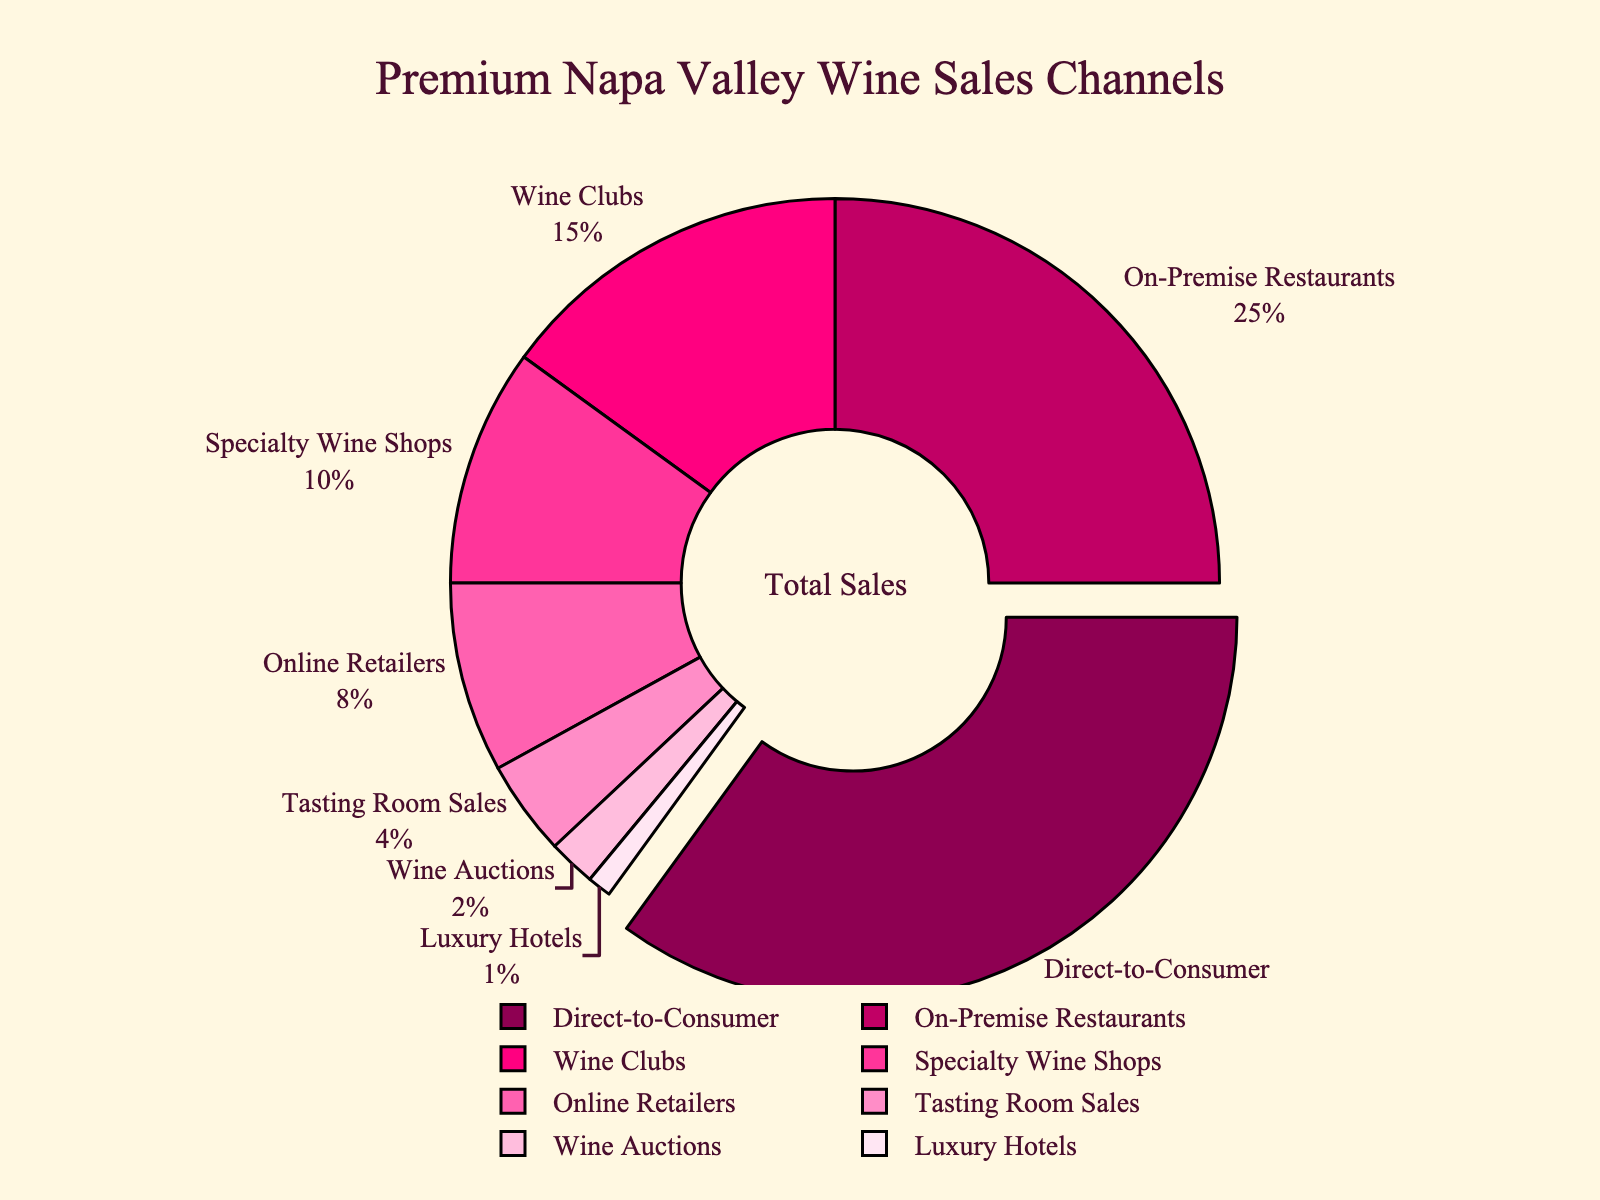what is the largest sales channel for premium Napa Valley wines? The largest sales channel is determined by the section with the greatest percentage. In this case, the "Direct-to-Consumer" section is pulled out and shows 35%
Answer: Direct-to-Consumer what percentage of sales is contributed by Wine Clubs and Specialty Wine Shops combined? Add the percentages of Wine Clubs (15%) and Specialty Wine Shops (10%). So, 15% + 10% = 25%
Answer: 25% which channel has the smallest share? Look for the smallest section in the pie chart. "Luxury Hotels" has the smallest share at 1%
Answer: Luxury Hotels how much more does the largest channel contribute compared to the smallest channel? Subtract the smallest percentage (1%, Luxury Hotels) from the largest percentage (35%, Direct-to-Consumer). 35% - 1% = 34%
Answer: 34% what is the total percentage of sales through online-related channels (Online Retailers and Wine Auctions)? Add the percentages for Online Retailers (8%) and Wine Auctions (2%). So, 8% + 2% = 10%
Answer: 10% are Wine Clubs more popular than On-Premise Restaurants? Compare the percentages: Wine Clubs (15%) and On-Premise Restaurants (25%). 15% is less than 25%, so On-Premise Restaurants are more popular
Answer: No which channels collectively cover at least half of the sales? List channels in descending order and sum the percentages until the total is at least 50%. Direct-to-Consumer (35%) + On-Premise Restaurants (25%) = 60%. These two channels cover more than half.
Answer: Direct-to-Consumer and On-Premise Restaurants if you exclude Direct-to-Consumer sales, what is the new percentage for On-Premise Restaurants? Subtract Direct-to-Consumer's share from total 100%. The remaining is 100% - 35% = 65%. On-Premise Restaurants is (25% of 65%) = (25/65)*100% ≈ 38.46%
Answer: Approximately 38.46% what proportion of total sales are made through Tasting Room Sales compared to Online Retailers? Calculate the ratio of the percentages: Tasting Room Sales (4%) to Online Retailers (8%). Ratio = 4% / 8% = 0.5
Answer: 0.5 